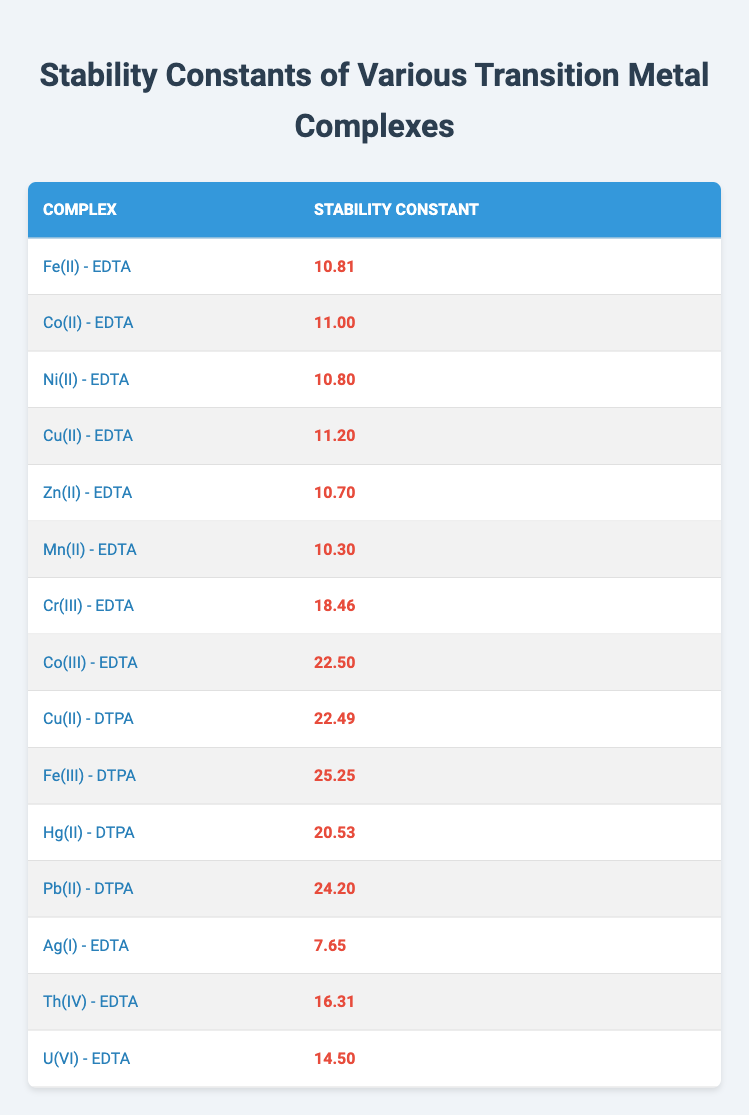What is the stability constant of Cu(II) - EDTA? The stability constant for the complex Cu(II) - EDTA is provided in the table. Directly referring to the corresponding row, the value is 11.20.
Answer: 11.20 Which transition metal complex has the highest stability constant? By examining the stability constants listed in the table, the complex with the highest value is Fe(III) - DTPA, which has a stability constant of 25.25.
Answer: 25.25 What is the stability constant for Ag(I) - EDTA? The value listed for Ag(I) - EDTA in the table shows that the stability constant is 7.65.
Answer: 7.65 What is the difference between the stability constants of Co(III) - EDTA and Mn(II) - EDTA? The stability constant for Co(III) - EDTA is 22.50, and for Mn(II) - EDTA, it is 10.30. The difference can be calculated as 22.50 - 10.30 = 12.20.
Answer: 12.20 Is the stability constant for U(VI) - EDTA greater than that of Ni(II) - EDTA? The stability constant for U(VI) - EDTA is 14.50, while Ni(II) - EDTA has a stability constant of 10.80. Since 14.50 is greater than 10.80, the statement is true.
Answer: Yes What is the average stability constant of all the complexes using EDTA? There are 8 complexes with EDTA. Adding their stability constants: (10.81 + 11.00 + 10.80 + 11.20 + 10.70 + 10.30 + 7.65 + 16.31) = 88.77. Dividing by the number of complexes (8): 88.77 / 8 = 11.09.
Answer: 11.09 Which complex has a stability constant greater than 20? By scanning the table, the complexes Co(III) - EDTA (22.50), Cu(II) - DTPA (22.49), Fe(III) - DTPA (25.25), and Pb(II) - DTPA (24.20) all have stability constants greater than 20.
Answer: Co(III) - EDTA, Cu(II) - DTPA, Fe(III) - DTPA, Pb(II) - DTPA What is the total stability constant of the complexes that use DTPA? The stability constants for the DTPA complexes are Cu(II) - DTPA (22.49), Fe(III) - DTPA (25.25), Hg(II) - DTPA (20.53), and Pb(II) - DTPA (24.20). Their total is 22.49 + 25.25 + 20.53 + 24.20 = 92.47.
Answer: 92.47 Which transition metal complex has the lowest stability constant? By checking the table, Ag(I) - EDTA has the lowest stability constant listed at 7.65.
Answer: Ag(I) - EDTA What can be concluded about the stability constants of the cobalt complexes? The stability constants for cobalt complexes are Co(II) - EDTA (11.00) and Co(III) - EDTA (22.50). Co(III) - EDTA has a significantly higher stability constant than Co(II) - EDTA, indicating that Co(III) complexes are generally more stable in this context.
Answer: Co(III) - EDTA has a higher stability constant than Co(II) - EDTA 